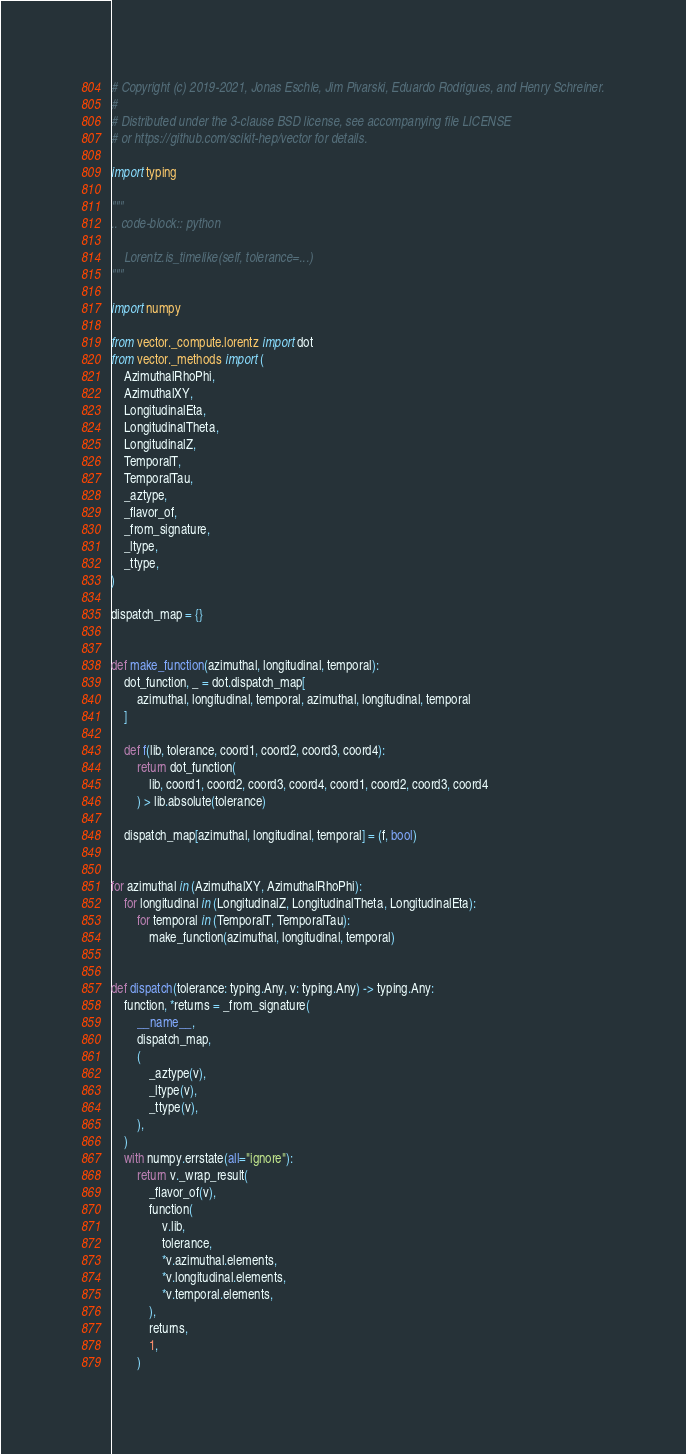<code> <loc_0><loc_0><loc_500><loc_500><_Python_># Copyright (c) 2019-2021, Jonas Eschle, Jim Pivarski, Eduardo Rodrigues, and Henry Schreiner.
#
# Distributed under the 3-clause BSD license, see accompanying file LICENSE
# or https://github.com/scikit-hep/vector for details.

import typing

"""
.. code-block:: python

    Lorentz.is_timelike(self, tolerance=...)
"""

import numpy

from vector._compute.lorentz import dot
from vector._methods import (
    AzimuthalRhoPhi,
    AzimuthalXY,
    LongitudinalEta,
    LongitudinalTheta,
    LongitudinalZ,
    TemporalT,
    TemporalTau,
    _aztype,
    _flavor_of,
    _from_signature,
    _ltype,
    _ttype,
)

dispatch_map = {}


def make_function(azimuthal, longitudinal, temporal):
    dot_function, _ = dot.dispatch_map[
        azimuthal, longitudinal, temporal, azimuthal, longitudinal, temporal
    ]

    def f(lib, tolerance, coord1, coord2, coord3, coord4):
        return dot_function(
            lib, coord1, coord2, coord3, coord4, coord1, coord2, coord3, coord4
        ) > lib.absolute(tolerance)

    dispatch_map[azimuthal, longitudinal, temporal] = (f, bool)


for azimuthal in (AzimuthalXY, AzimuthalRhoPhi):
    for longitudinal in (LongitudinalZ, LongitudinalTheta, LongitudinalEta):
        for temporal in (TemporalT, TemporalTau):
            make_function(azimuthal, longitudinal, temporal)


def dispatch(tolerance: typing.Any, v: typing.Any) -> typing.Any:
    function, *returns = _from_signature(
        __name__,
        dispatch_map,
        (
            _aztype(v),
            _ltype(v),
            _ttype(v),
        ),
    )
    with numpy.errstate(all="ignore"):
        return v._wrap_result(
            _flavor_of(v),
            function(
                v.lib,
                tolerance,
                *v.azimuthal.elements,
                *v.longitudinal.elements,
                *v.temporal.elements,
            ),
            returns,
            1,
        )
</code> 